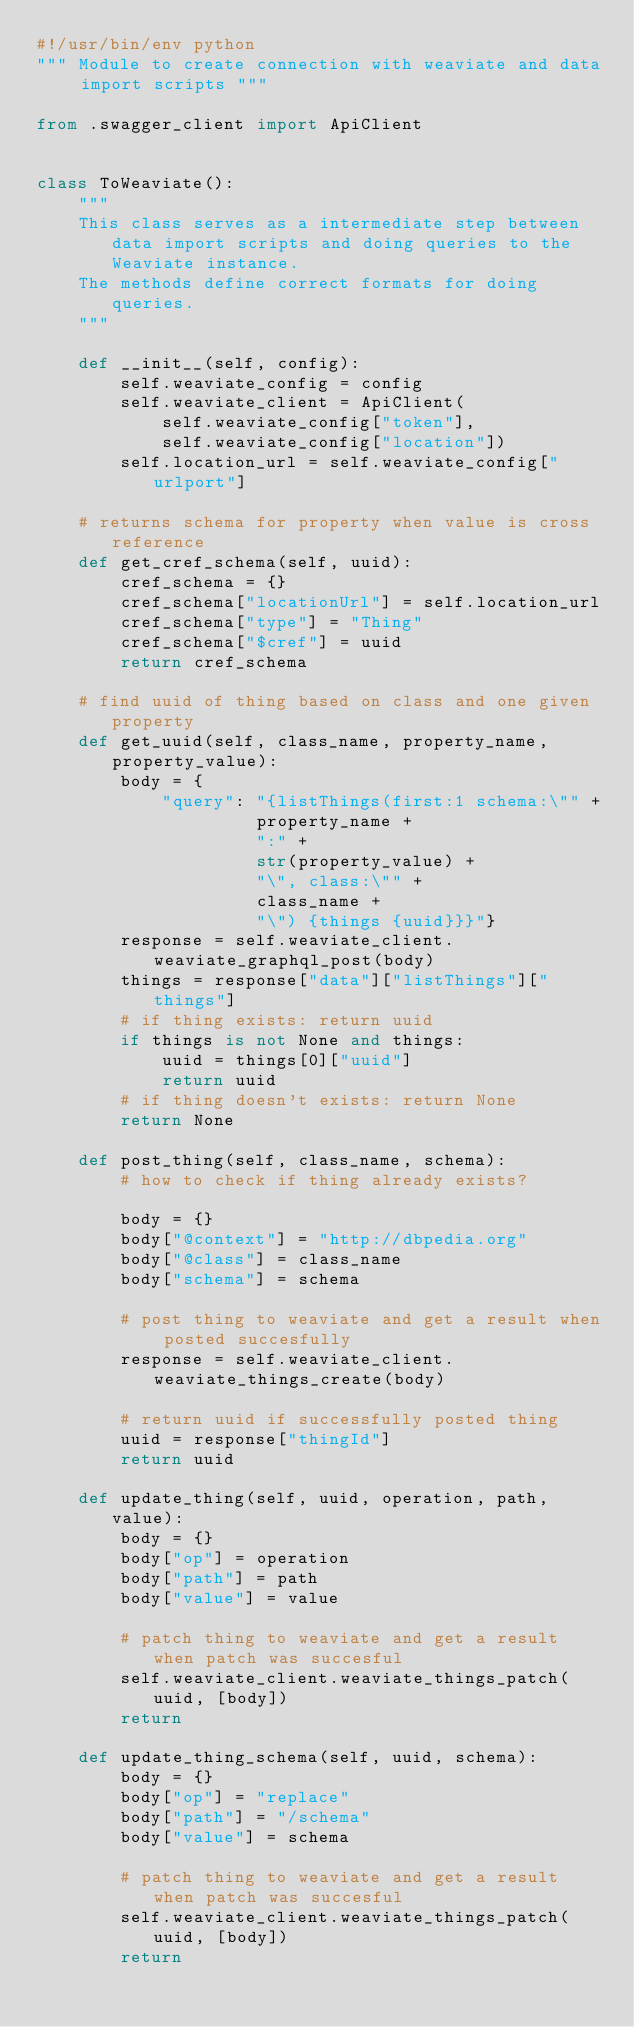<code> <loc_0><loc_0><loc_500><loc_500><_Python_>#!/usr/bin/env python
""" Module to create connection with weaviate and data import scripts """

from .swagger_client import ApiClient


class ToWeaviate():
    """
    This class serves as a intermediate step between data import scripts and doing queries to the Weaviate instance.
    The methods define correct formats for doing queries.
    """

    def __init__(self, config):
        self.weaviate_config = config
        self.weaviate_client = ApiClient(
            self.weaviate_config["token"],
            self.weaviate_config["location"])
        self.location_url = self.weaviate_config["urlport"]

    # returns schema for property when value is cross reference
    def get_cref_schema(self, uuid):
        cref_schema = {}
        cref_schema["locationUrl"] = self.location_url
        cref_schema["type"] = "Thing"
        cref_schema["$cref"] = uuid
        return cref_schema

    # find uuid of thing based on class and one given property
    def get_uuid(self, class_name, property_name, property_value):
        body = {
            "query": "{listThings(first:1 schema:\"" +
                     property_name +
                     ":" +
                     str(property_value) +
                     "\", class:\"" +
                     class_name +
                     "\") {things {uuid}}}"}
        response = self.weaviate_client.weaviate_graphql_post(body)
        things = response["data"]["listThings"]["things"]
        # if thing exists: return uuid
        if things is not None and things:
            uuid = things[0]["uuid"]
            return uuid
        # if thing doesn't exists: return None
        return None

    def post_thing(self, class_name, schema):
        # how to check if thing already exists?

        body = {}
        body["@context"] = "http://dbpedia.org"
        body["@class"] = class_name
        body["schema"] = schema

        # post thing to weaviate and get a result when posted succesfully
        response = self.weaviate_client.weaviate_things_create(body)

        # return uuid if successfully posted thing
        uuid = response["thingId"]
        return uuid

    def update_thing(self, uuid, operation, path, value):
        body = {}
        body["op"] = operation
        body["path"] = path
        body["value"] = value

        # patch thing to weaviate and get a result when patch was succesful
        self.weaviate_client.weaviate_things_patch(uuid, [body])
        return

    def update_thing_schema(self, uuid, schema):
        body = {}
        body["op"] = "replace"
        body["path"] = "/schema"
        body["value"] = schema

        # patch thing to weaviate and get a result when patch was succesful
        self.weaviate_client.weaviate_things_patch(uuid, [body])
        return
</code> 